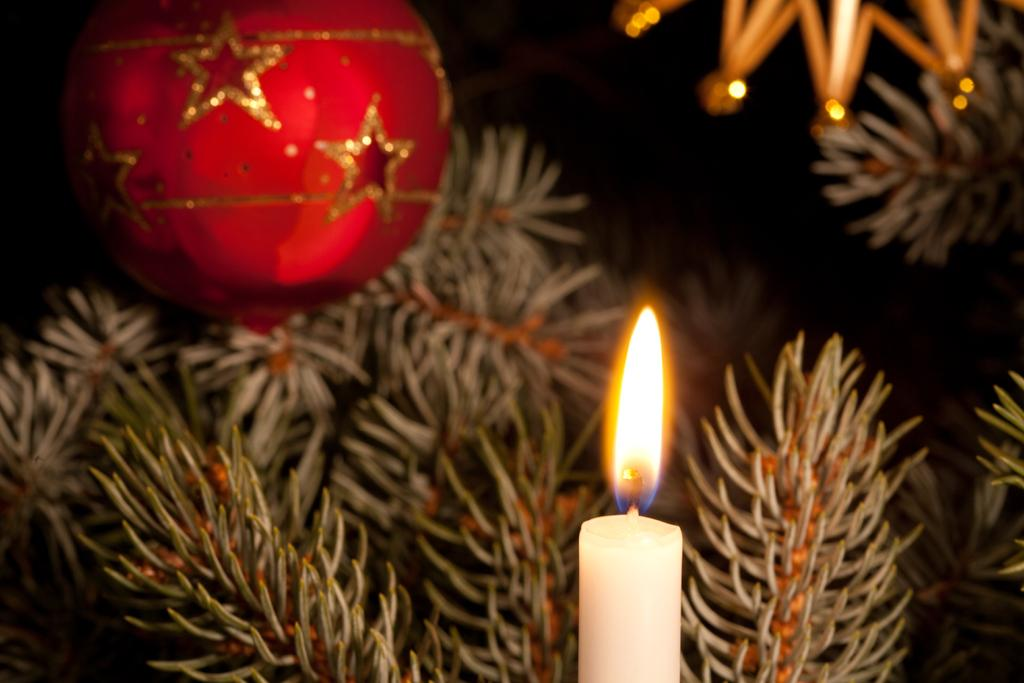What is the main object in the image? There is a candle in the image. What else can be seen in the image besides the candle? There are plants and decorative products in the image. How many family members are present in the image? There is no indication of any family members in the image. What is the unit of measurement for the size of the candle in the image? The size of the candle is not specified in the image, so it's not possible to determine a unit of measurement. 